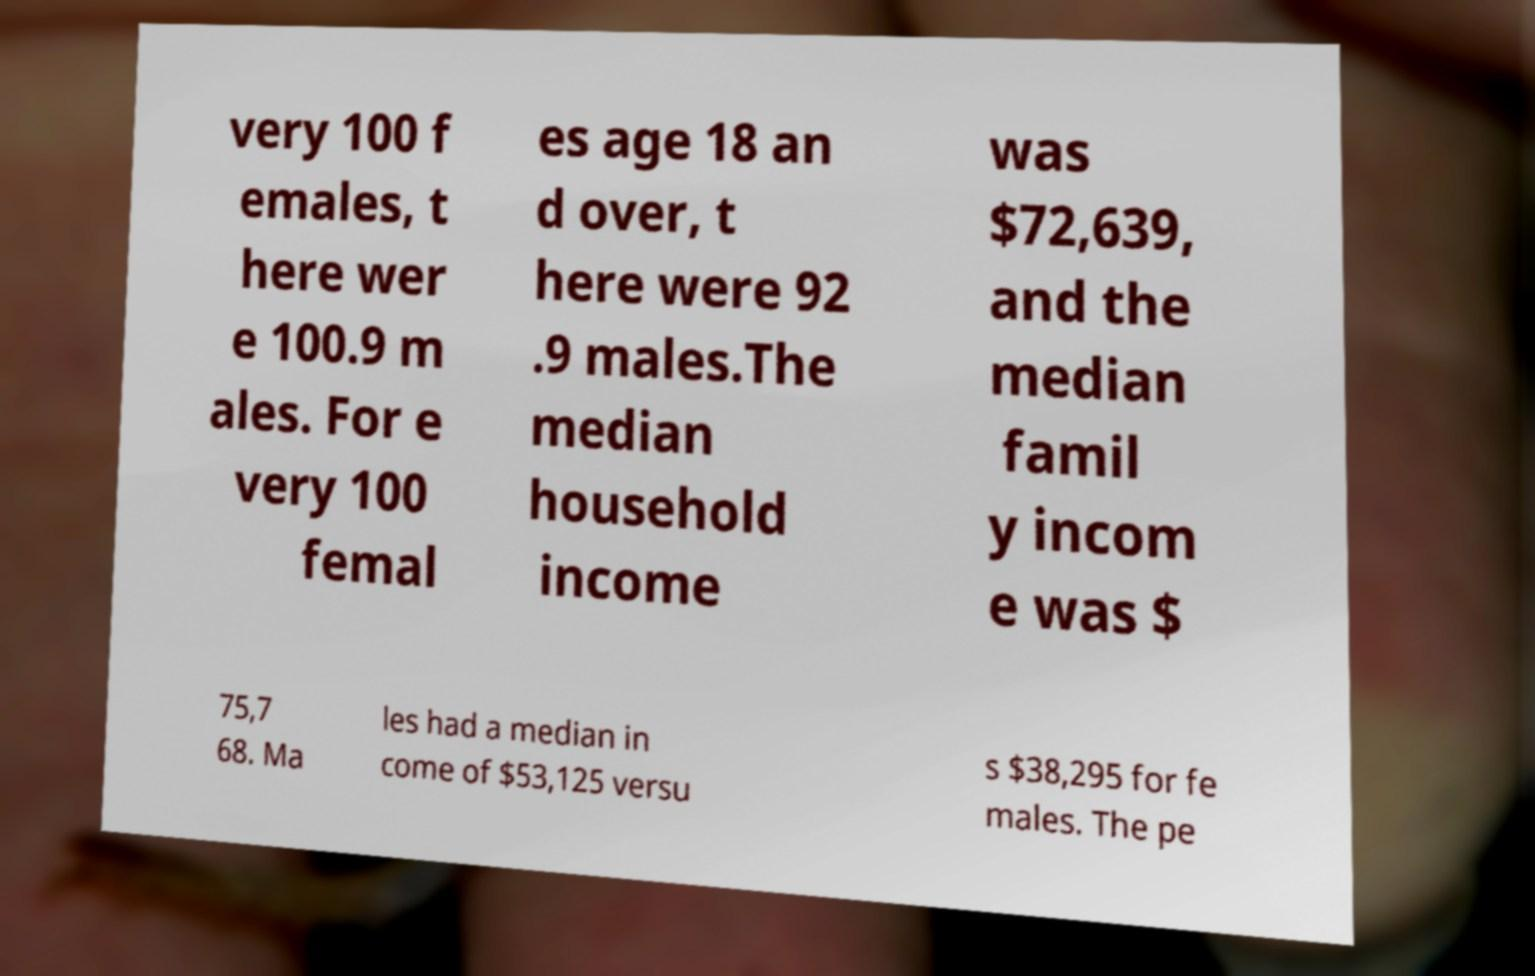For documentation purposes, I need the text within this image transcribed. Could you provide that? very 100 f emales, t here wer e 100.9 m ales. For e very 100 femal es age 18 an d over, t here were 92 .9 males.The median household income was $72,639, and the median famil y incom e was $ 75,7 68. Ma les had a median in come of $53,125 versu s $38,295 for fe males. The pe 